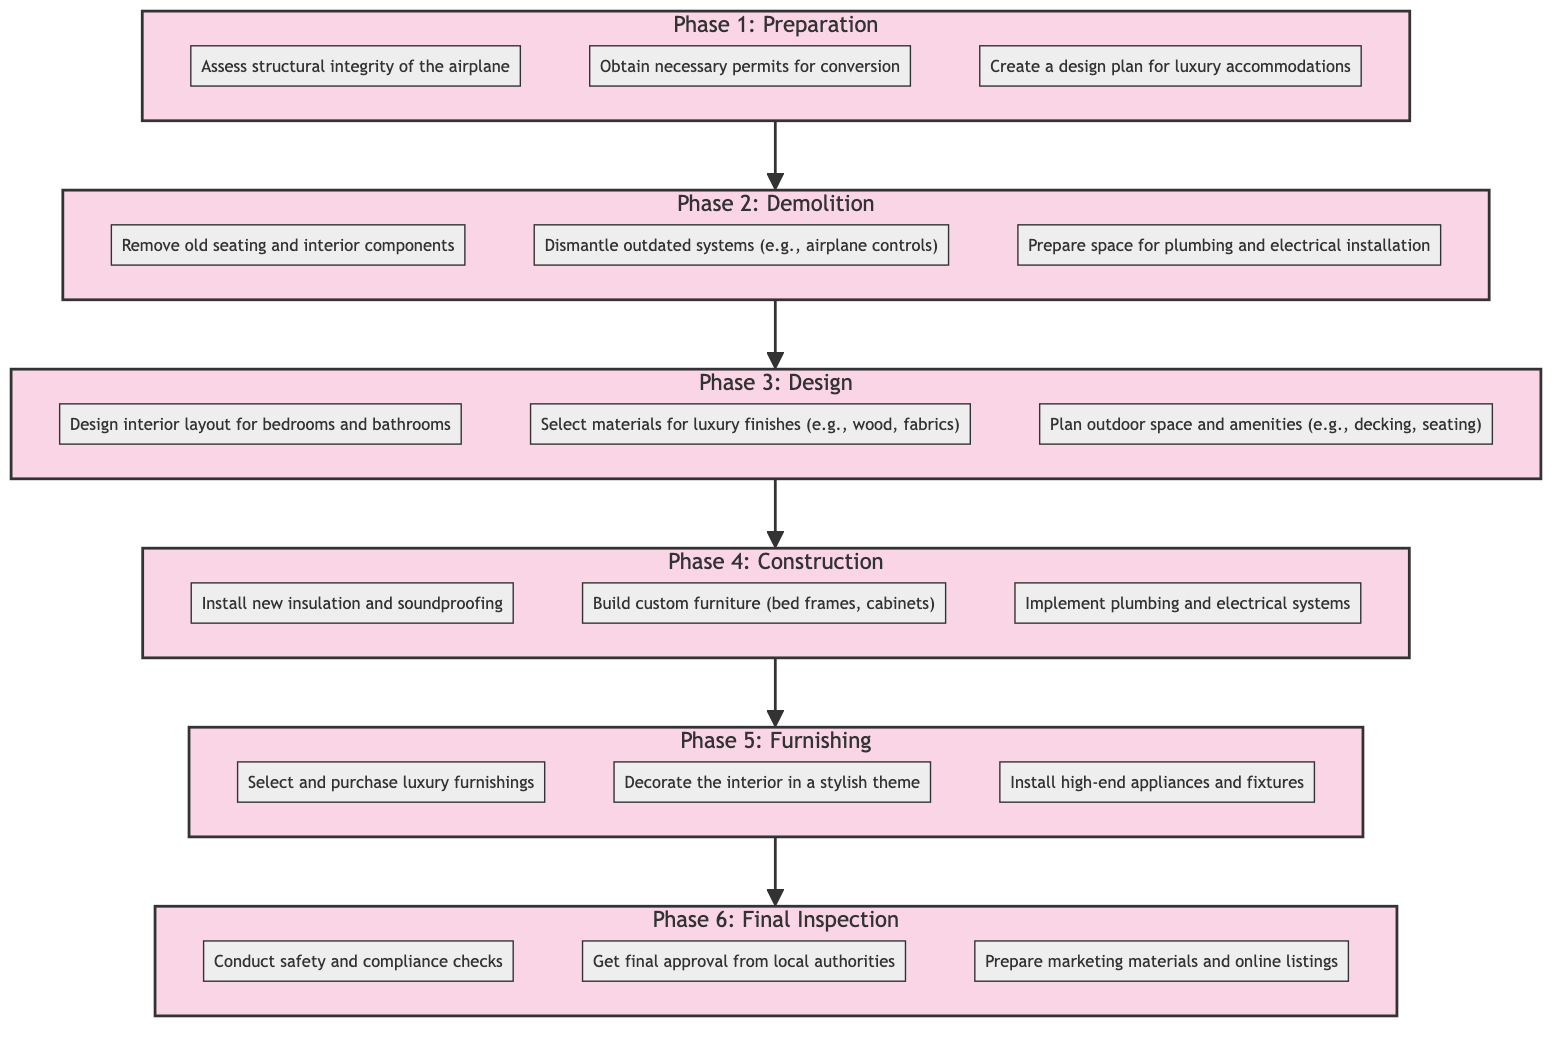What is the final phase of the renovation project? The diagram indicates that Phase 6 is the "Final Inspection," which is the last phase in the outlined renovation project.
Answer: Final Inspection How many tasks are in Phase 3? By inspecting Phase 3, we see there are three tasks listed: design interior layout, select materials, and plan outdoor space. Thus, the total is three tasks.
Answer: 3 What task comes immediately after assessing structural integrity? Looking through the flowchart, after the task "Assess structural integrity of the airplane" in Phase 1, the next task is "Obtain necessary permits for conversion" in Phase 1.
Answer: Obtain necessary permits for conversion Which phase involves the installation of high-end appliances? In the diagram, the "Furnishing" phase (Phase 5) includes the task "Install high-end appliances and fixtures." So, the phase that involves this installation is Phase 5.
Answer: Phase 5: Furnishing What is the relationship between Phase 2 and Phase 3? The relationship displayed in the diagram shows that Phase 2 (Demolition) flows directly into Phase 3 (Design), indicating that completion of demolition tasks is a prerequisite for starting design tasks.
Answer: Phase 2 leads to Phase 3 How many tasks are in the entire renovation project? By counting the tasks across all phases in the diagram: Phase 1 has 3, Phase 2 has 3, Phase 3 has 3, Phase 4 has 3, Phase 5 has 3, and Phase 6 has 3, the total number of tasks equals 18.
Answer: 18 What is the second task in Phase 4? Looking at Phase 4, the tasks listed are in sequential order: "Install new insulation and soundproofing" is first, and "Build custom furniture (bed frames, cabinets)" is the second task.
Answer: Build custom furniture (bed frames, cabinets) What type of renovation is this project focused on? The overall theme of the renovation project, as per the title of the flowchart, is to transform an airplane into a luxury Airbnb, highlighting the luxury aspect of the conversion.
Answer: Luxury Airbnb 